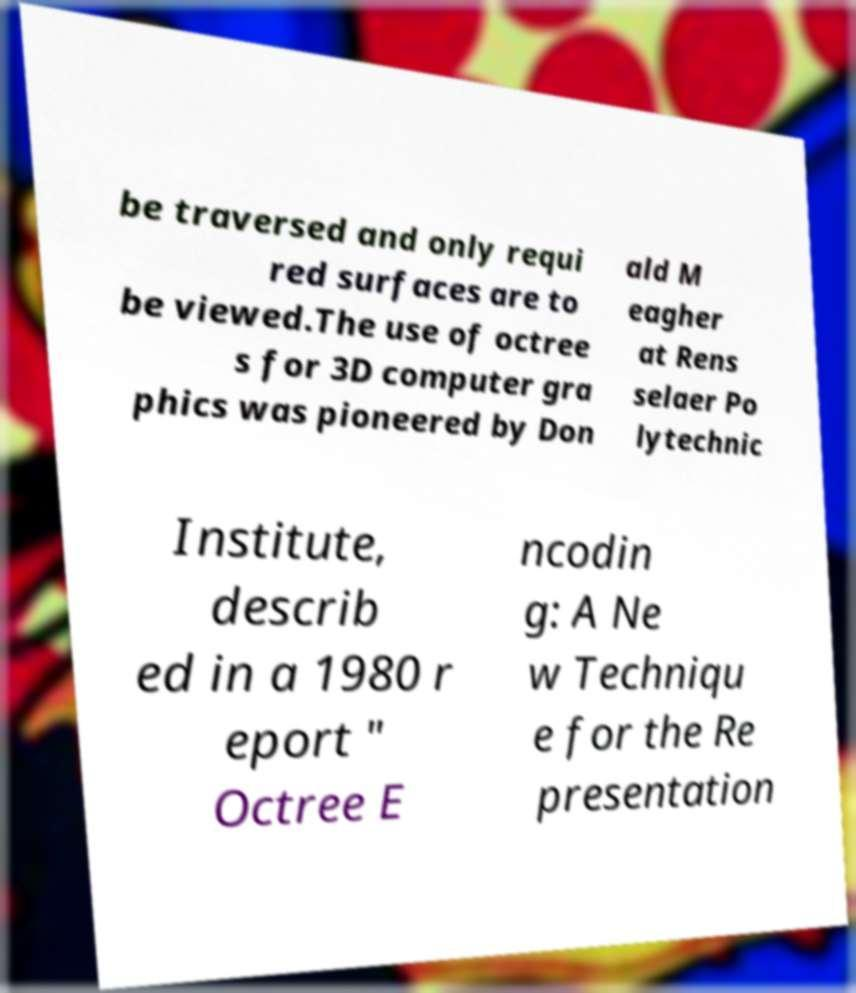What messages or text are displayed in this image? I need them in a readable, typed format. be traversed and only requi red surfaces are to be viewed.The use of octree s for 3D computer gra phics was pioneered by Don ald M eagher at Rens selaer Po lytechnic Institute, describ ed in a 1980 r eport " Octree E ncodin g: A Ne w Techniqu e for the Re presentation 